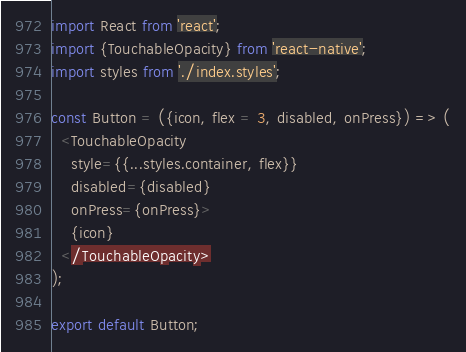Convert code to text. <code><loc_0><loc_0><loc_500><loc_500><_JavaScript_>import React from 'react';
import {TouchableOpacity} from 'react-native';
import styles from './index.styles';

const Button = ({icon, flex = 3, disabled, onPress}) => (
  <TouchableOpacity
    style={{...styles.container, flex}}
    disabled={disabled}
    onPress={onPress}>
    {icon}
  </TouchableOpacity>
);

export default Button;
</code> 